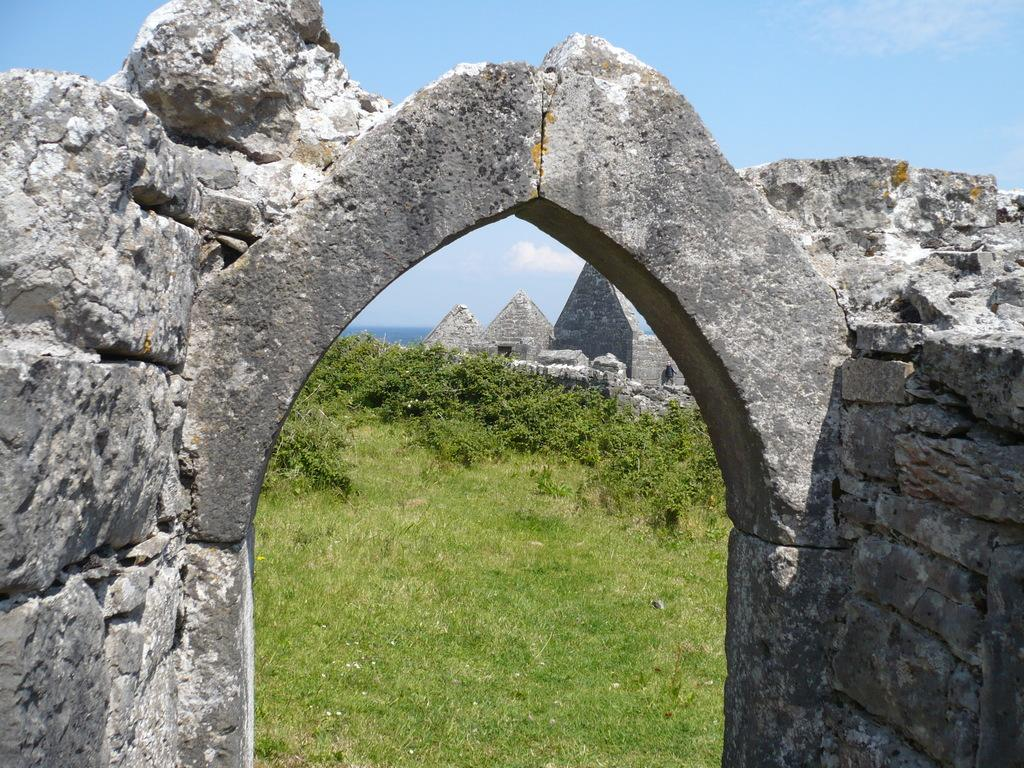What type of structure can be seen in the image? There is an arch in the image. What type of vegetation is present in the image? There is grass and trees in the image. What type of material is used for the walls in the image? There are walls in the image, but the material is not specified. What type of ground surface is visible in the image? There are stones in the image, which may indicate the ground surface. What is visible in the background of the image? The sky is visible in the background of the image. Can you tell me how many breaths the trees are taking in the image? Trees do not breathe like humans or animals, so this question cannot be answered. What type of bedroom can be seen in the image? There is no bedroom present in the image. 